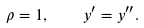<formula> <loc_0><loc_0><loc_500><loc_500>\rho = 1 , \quad y ^ { \prime } = y ^ { \prime \prime } .</formula> 